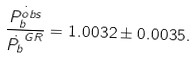Convert formula to latex. <formula><loc_0><loc_0><loc_500><loc_500>\frac { \dot { P _ { b } ^ { o b s } } } { \dot { P _ { b } } ^ { G R } } = 1 . 0 0 3 2 \pm 0 . 0 0 3 5 .</formula> 